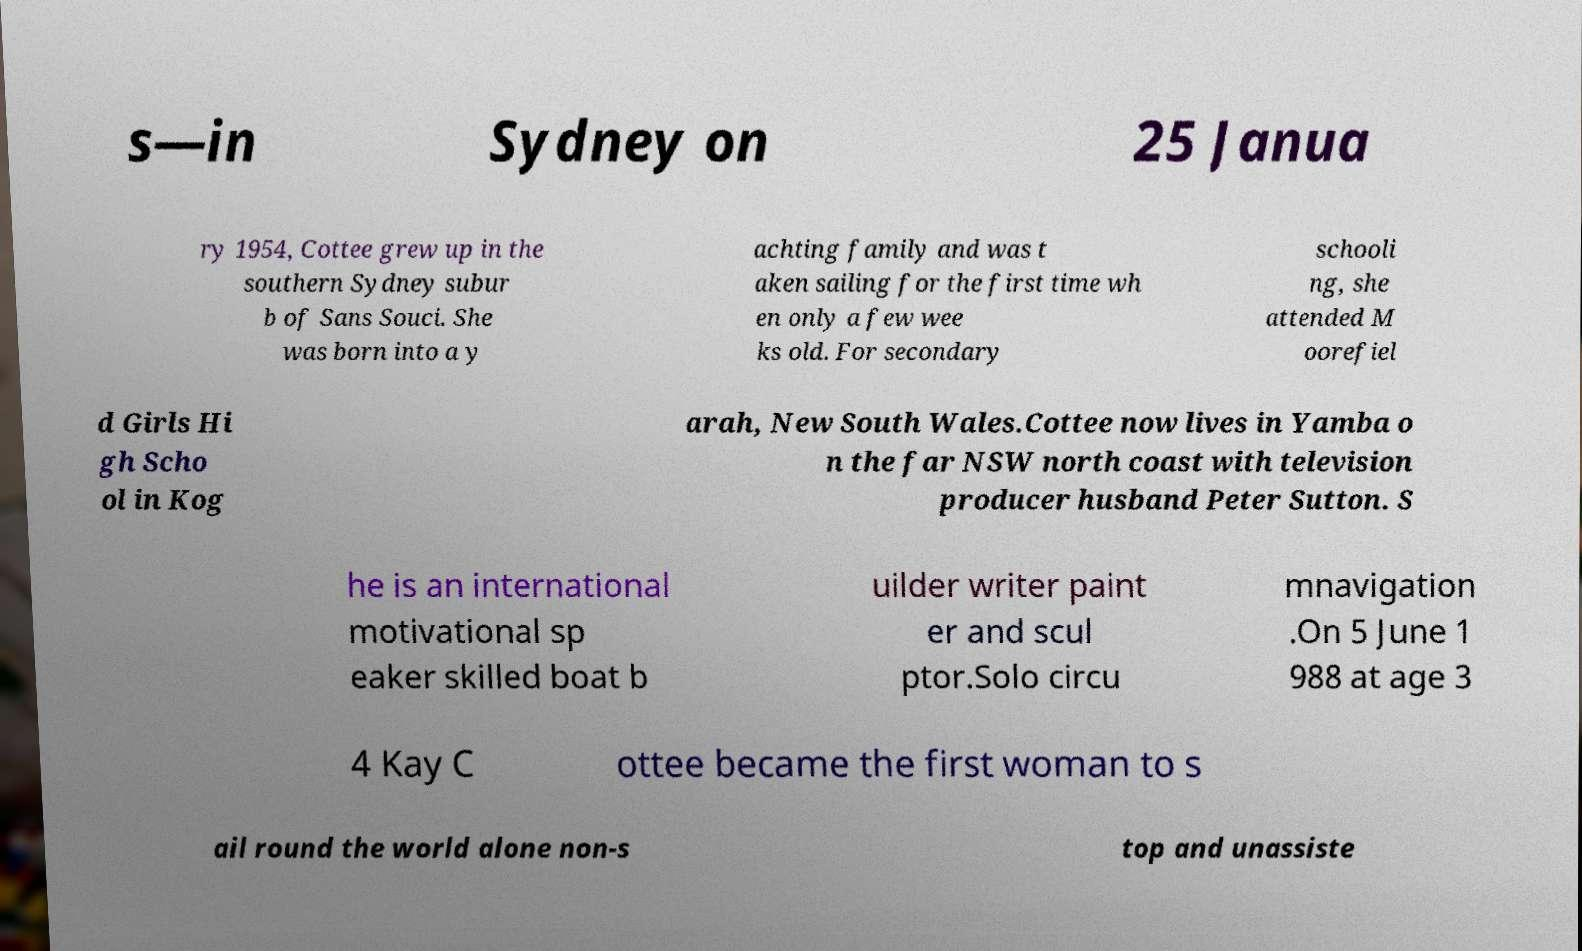For documentation purposes, I need the text within this image transcribed. Could you provide that? s—in Sydney on 25 Janua ry 1954, Cottee grew up in the southern Sydney subur b of Sans Souci. She was born into a y achting family and was t aken sailing for the first time wh en only a few wee ks old. For secondary schooli ng, she attended M oorefiel d Girls Hi gh Scho ol in Kog arah, New South Wales.Cottee now lives in Yamba o n the far NSW north coast with television producer husband Peter Sutton. S he is an international motivational sp eaker skilled boat b uilder writer paint er and scul ptor.Solo circu mnavigation .On 5 June 1 988 at age 3 4 Kay C ottee became the first woman to s ail round the world alone non-s top and unassiste 